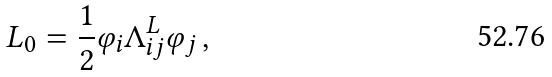<formula> <loc_0><loc_0><loc_500><loc_500>L _ { 0 } = \frac { 1 } { 2 } \varphi _ { i } \Lambda _ { i j } ^ { L } \varphi _ { j } \, ,</formula> 